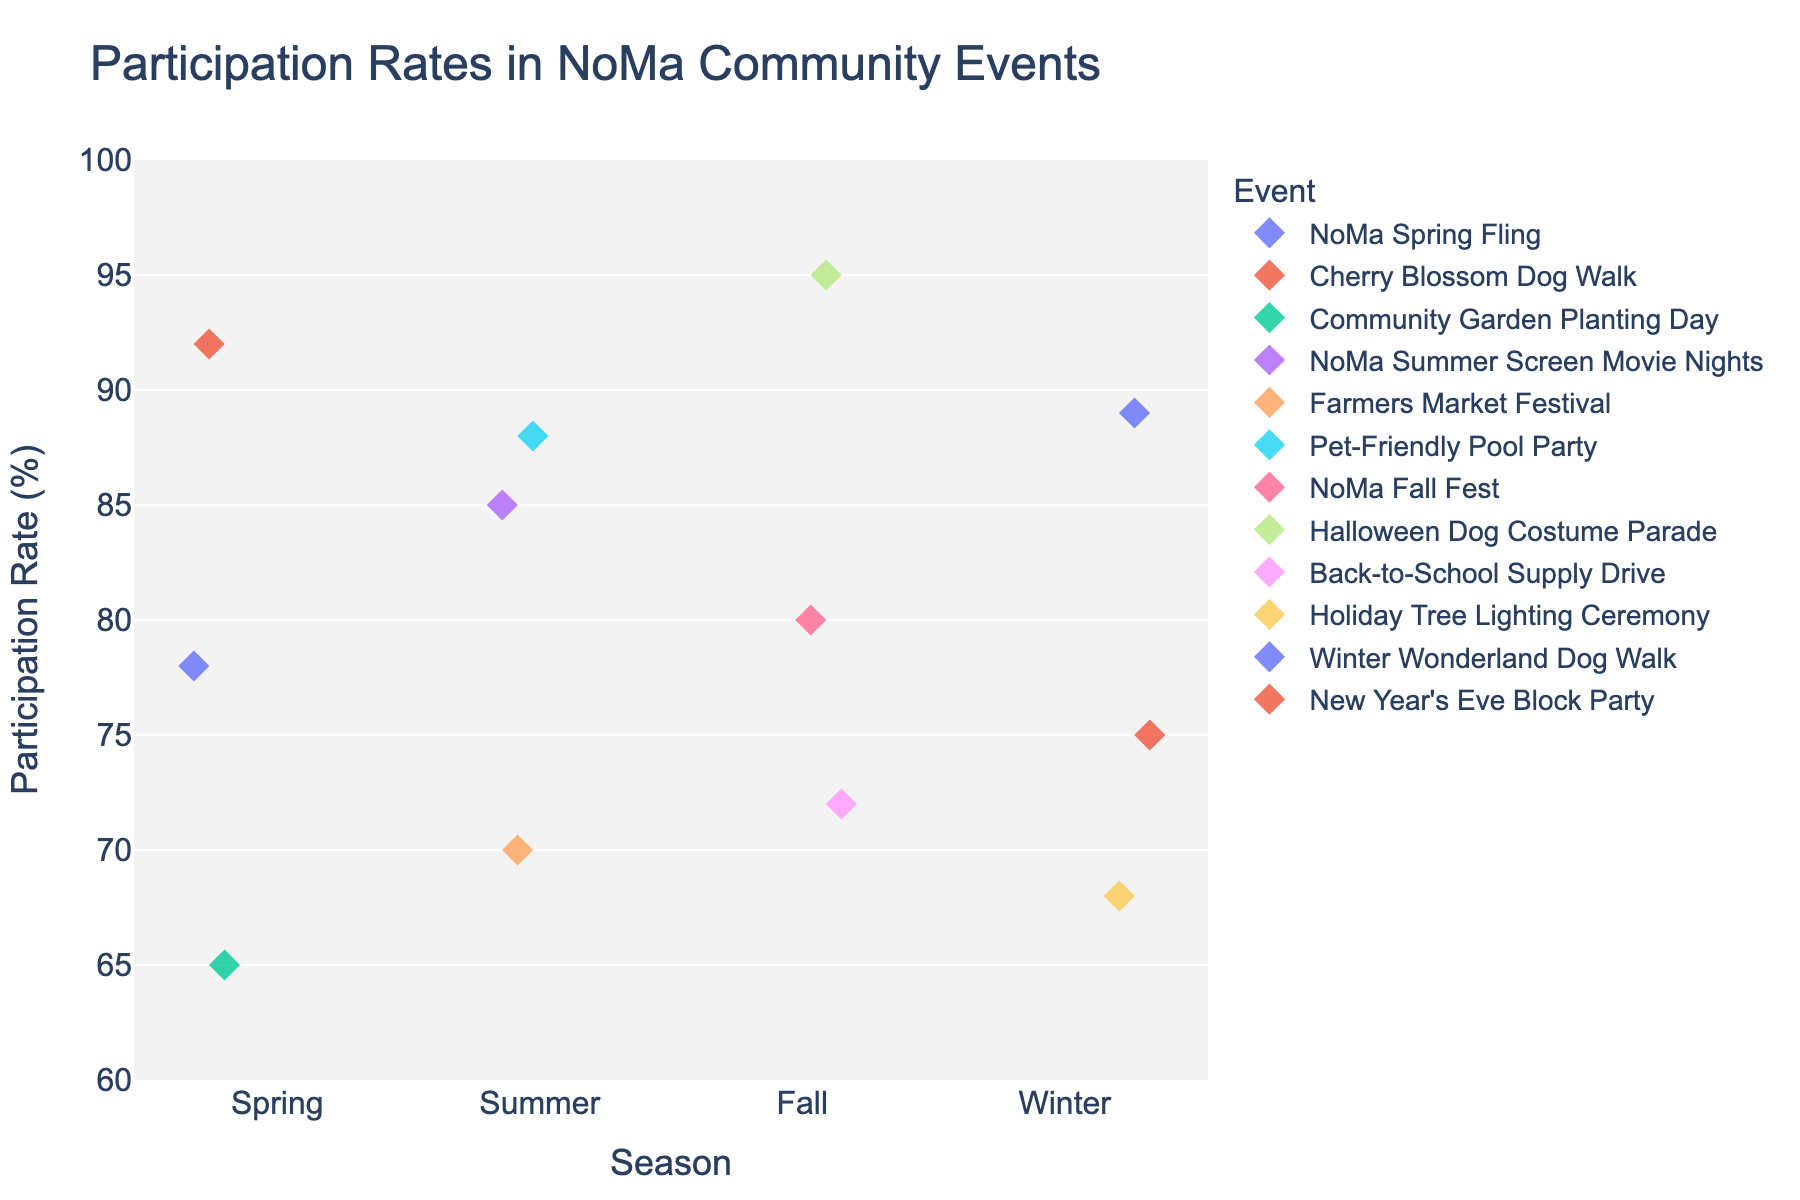What's the title of the figure? The title of the figure is usually found at the top of the plot. It provides a brief description of what the figure represents. Here, it shows "Participation Rates in NoMa Community Events".
Answer: Participation Rates in NoMa Community Events Which event in Spring had the highest participation rate? To find this, locate the "Spring" section on the x-axis and identify the event with the highest position on the y-axis. The "Cherry Blossom Dog Walk" has the highest participation rate.
Answer: Cherry Blossom Dog Walk What is the average participation rate for events in Winter? Find all participation rates under the "Winter" category on the plot: 68, 89, and 75. Sum these up (68 + 89 + 75 = 232) and divide by the number of events (3) to get the average (232 / 3 = 77.33).
Answer: 77.33 Which season has the most diverse range of participation rates? To determine the diversity, examine the spread of participation rates for each season. The "Winter" season has the widest spread from 68 to 89, indicating the most diverse range.
Answer: Winter Compare the highest and lowest participation rates across all seasons. What is the difference? Identify the highest rate (95) in "Fall" and the lowest rate (65) in "Spring". Subtract the lowest from the highest (95 - 65 = 30).
Answer: 30 Is there any event that has a participation rate over 90%? Look across all events for any dot located above the 90% mark on the y-axis. There are two: "Cherry Blossom Dog Walk" (Spring) and "Halloween Dog Costume Parade" (Fall).
Answer: Yes How many events have a participation rate above 80% in Summer? Check the "Summer" section and count how many dots are at 80% or higher: 85 (NoMa Summer Screen Movie Nights) and 88 (Pet-Friendly Pool Party).
Answer: 2 Which season has the highest average participation rate? Calculate the average participation rate for each season and compare them. 
Spring: (78 + 92 + 65) / 3 = 78.33
Summer: (85 + 70 + 88) / 3 = 81
Fall: (80 + 95 + 72) / 3 = 82.33
Winter: (68 + 89 + 75) / 3 = 77.33 
Fall has the highest average.
Answer: Fall What event in Fall has the second highest participation rate and what is that rate? Look at the "Fall" layer and identify the points, then arrange the rates: 95, 80, and 72. The second highest is the "NoMa Fall Fest" with a rate of 80.
Answer: NoMa Fall Fest, 80 